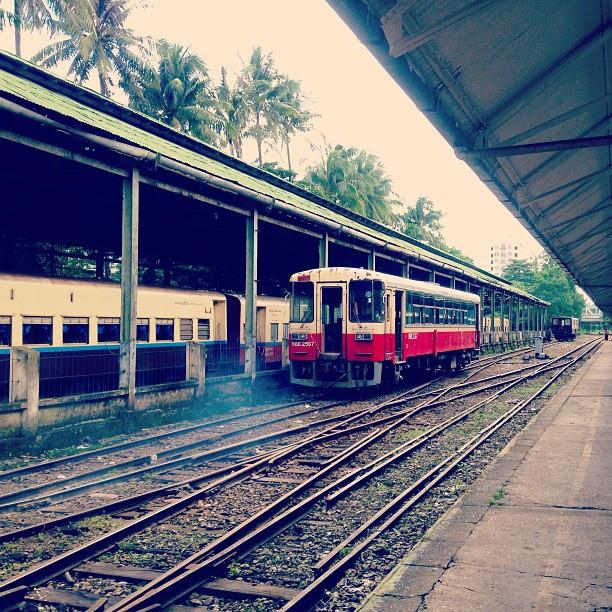Is this a train station?
Quick response, please. Yes. How many sets of track are there?
Concise answer only. 4. What color is the bottom of the train?
Short answer required. Red. 